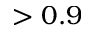<formula> <loc_0><loc_0><loc_500><loc_500>> 0 . 9</formula> 